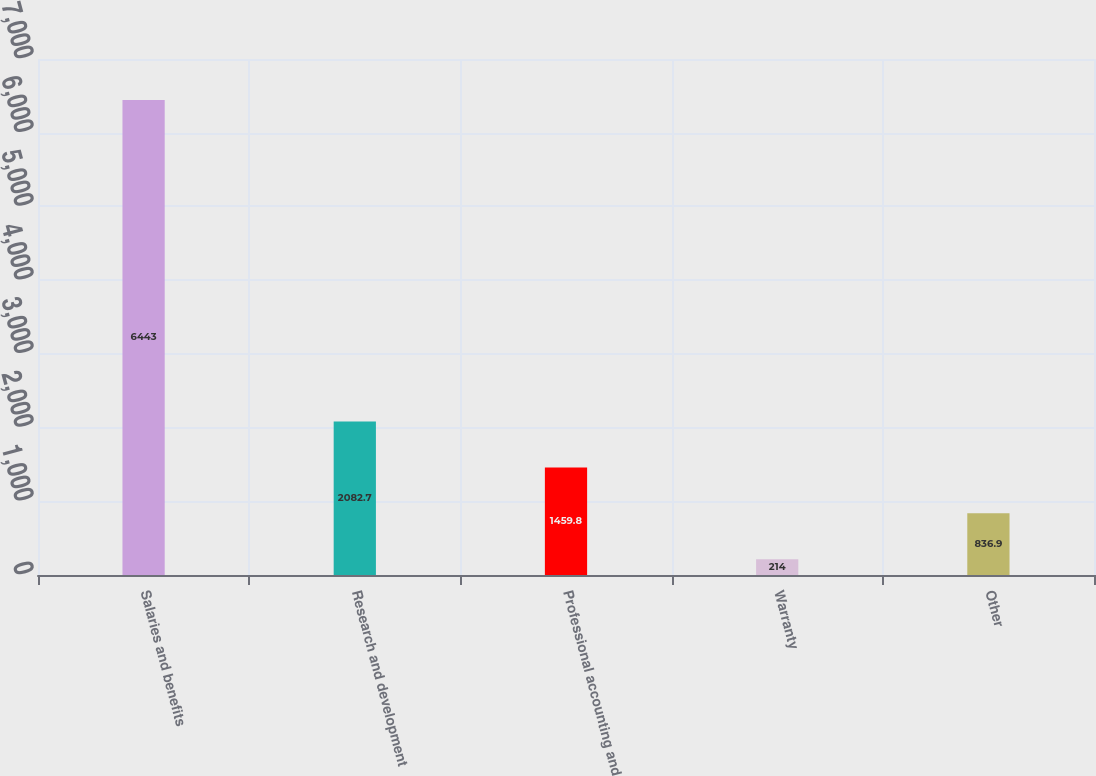Convert chart. <chart><loc_0><loc_0><loc_500><loc_500><bar_chart><fcel>Salaries and benefits<fcel>Research and development<fcel>Professional accounting and<fcel>Warranty<fcel>Other<nl><fcel>6443<fcel>2082.7<fcel>1459.8<fcel>214<fcel>836.9<nl></chart> 